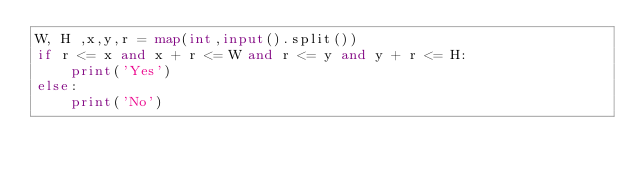<code> <loc_0><loc_0><loc_500><loc_500><_Python_>W, H ,x,y,r = map(int,input().split())
if r <= x and x + r <= W and r <= y and y + r <= H:
    print('Yes')
else:
    print('No')
</code> 